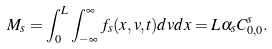Convert formula to latex. <formula><loc_0><loc_0><loc_500><loc_500>M _ { s } = \int _ { 0 } ^ { L } \int _ { - \infty } ^ { \infty } f _ { s } ( x , v , t ) d v d x = L \alpha _ { s } C _ { 0 , 0 } ^ { s } .</formula> 